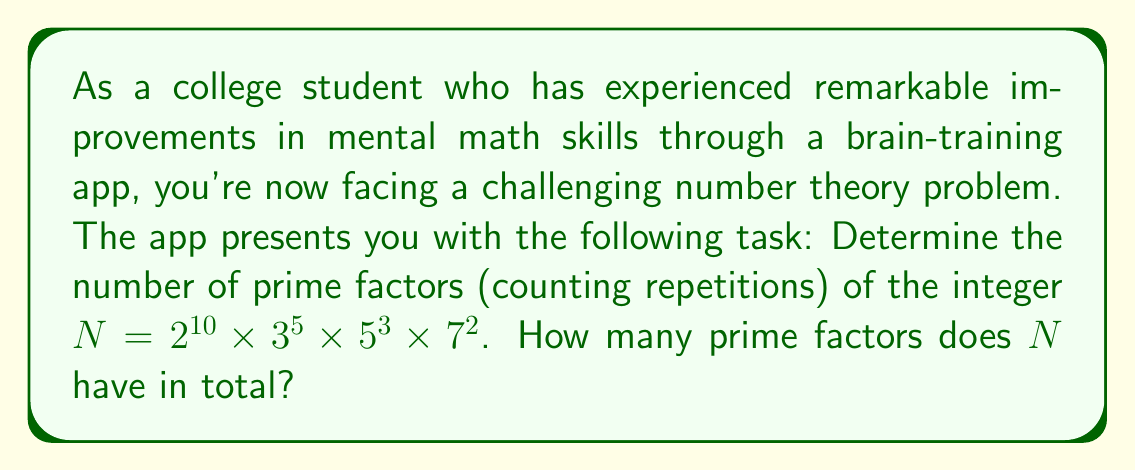Solve this math problem. Let's approach this step-by-step:

1) First, let's recall that in the prime factorization $2^{10} \times 3^5 \times 5^3 \times 7^2$, each base (2, 3, 5, 7) is a prime number, and the exponents tell us how many times each prime factor appears.

2) Let's count the prime factors:
   
   - $2^{10}$ contributes 10 factors of 2
   - $3^5$ contributes 5 factors of 3
   - $5^3$ contributes 3 factors of 5
   - $7^2$ contributes 2 factors of 7

3) To get the total number of prime factors, we sum these counts:

   $$ 10 + 5 + 3 + 2 = 20 $$

Therefore, $N$ has 20 prime factors in total, counting repetitions.
Answer: 20 